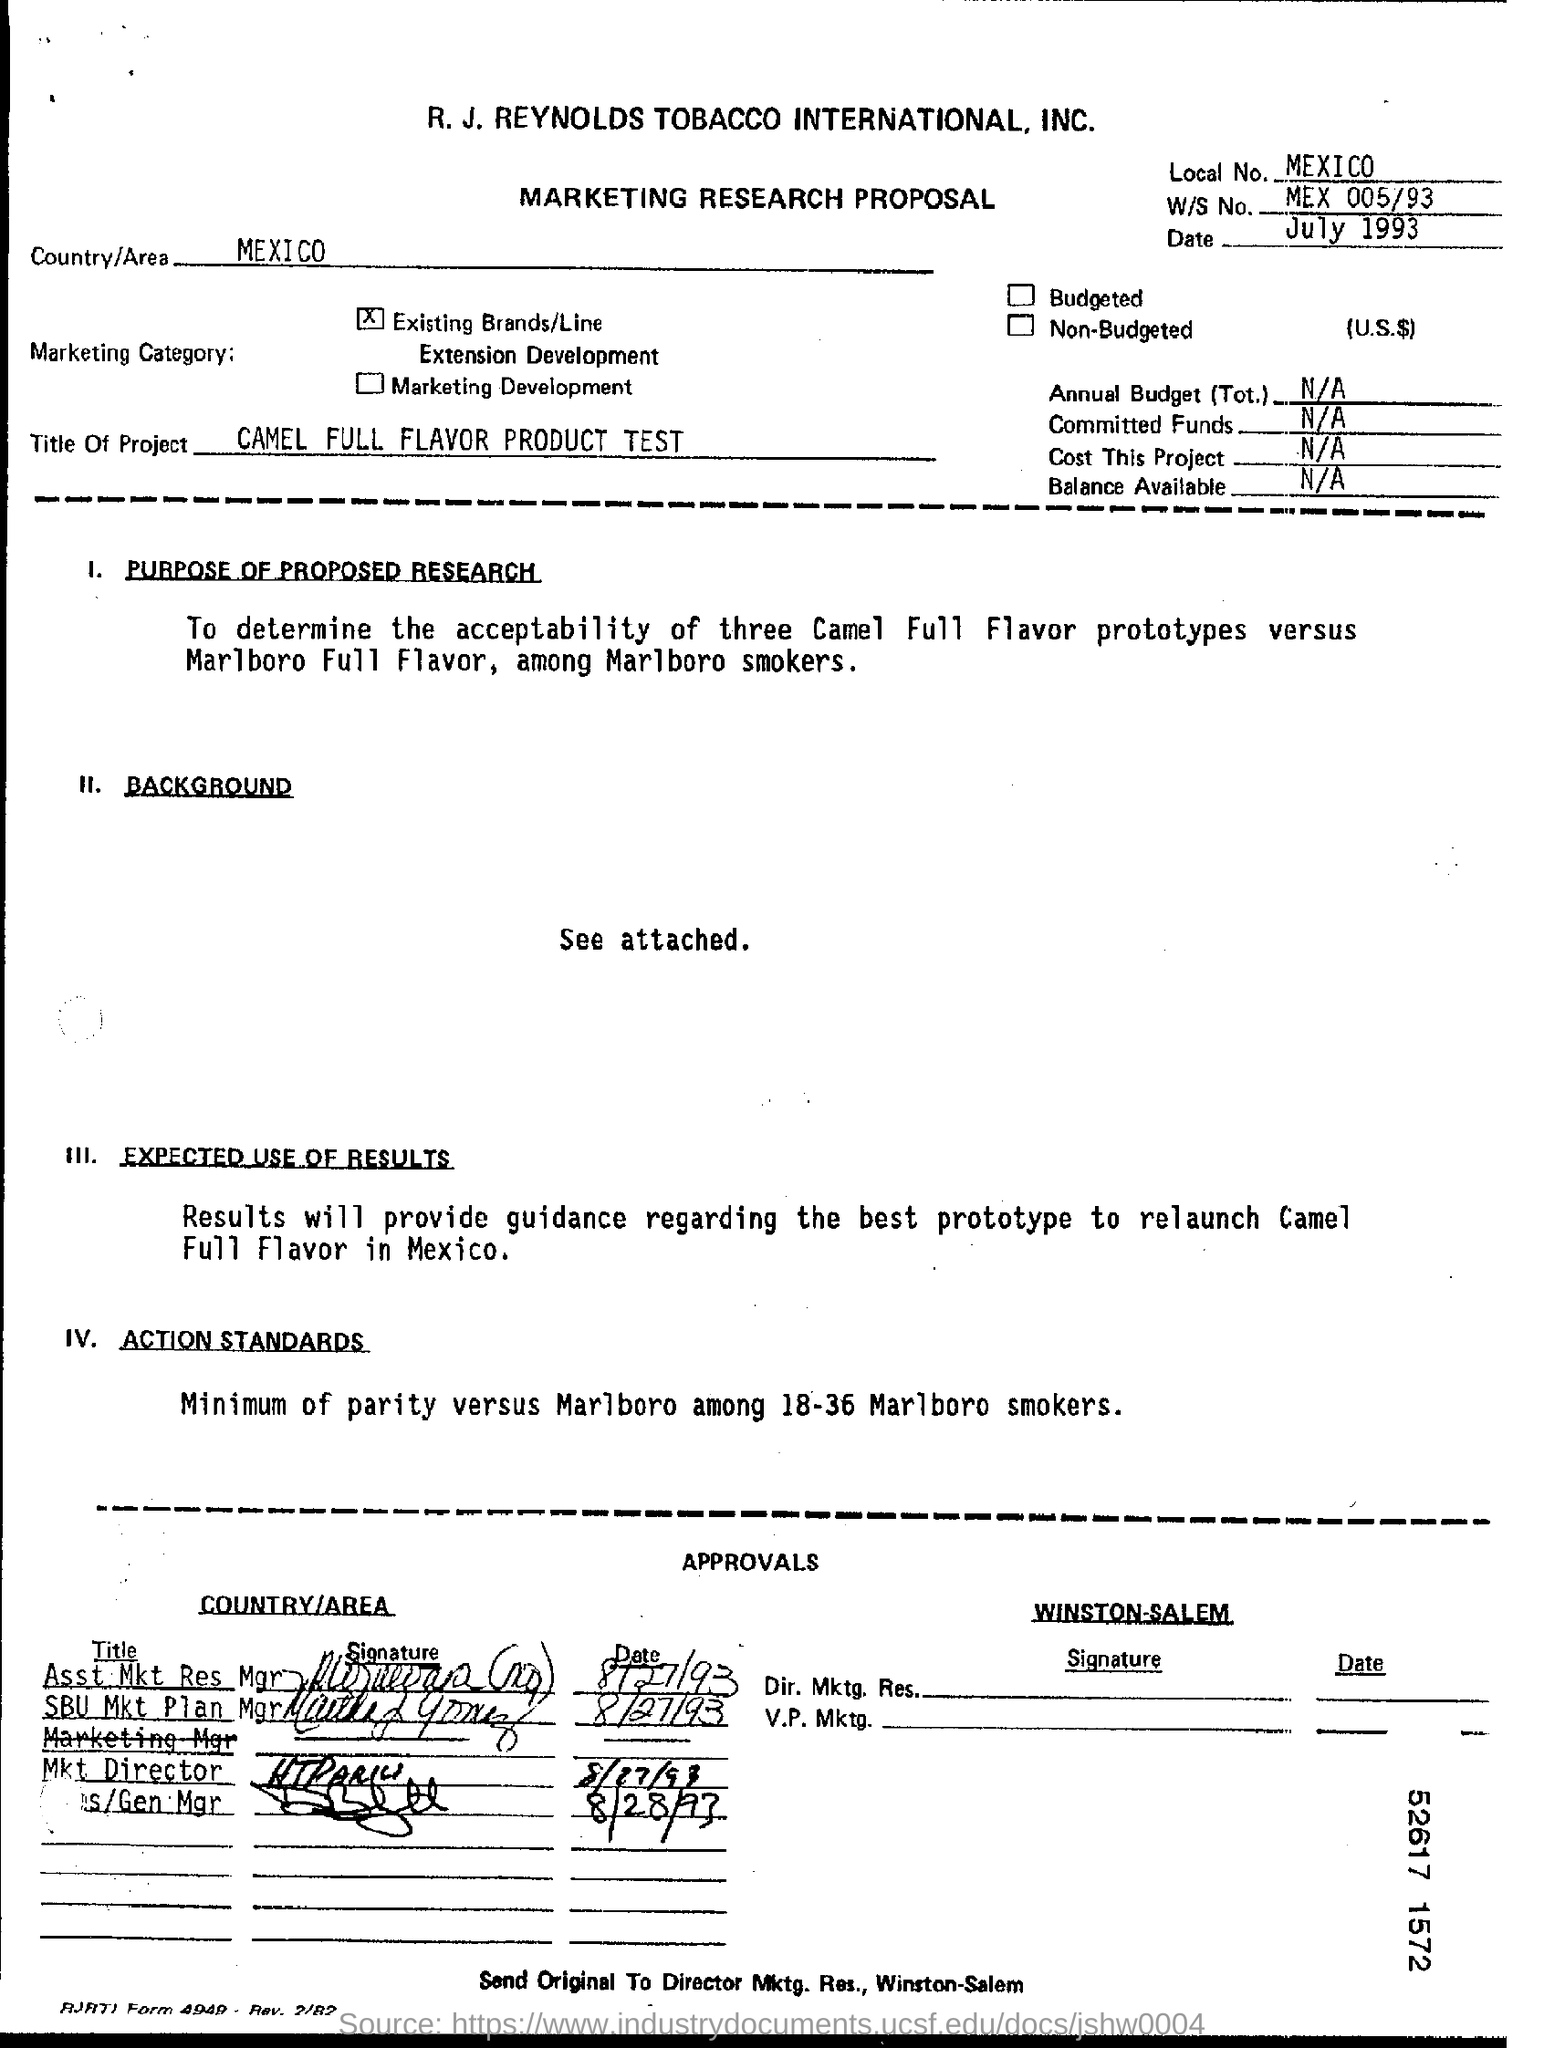Mention a couple of crucial points in this snapshot. The date mentioned at the top of the document is July 1993. The main heading of the document is: Marketing Research Proposal. What is W/S No? MEX 005/93..." is a question asking for information about a specific number or identifier, possibly related to a work or project. What is the local number? It is from Mexico. The project titled 'Camel Full Flavor Product Test' aims to evaluate the taste and quality of various products offered by Camel. 